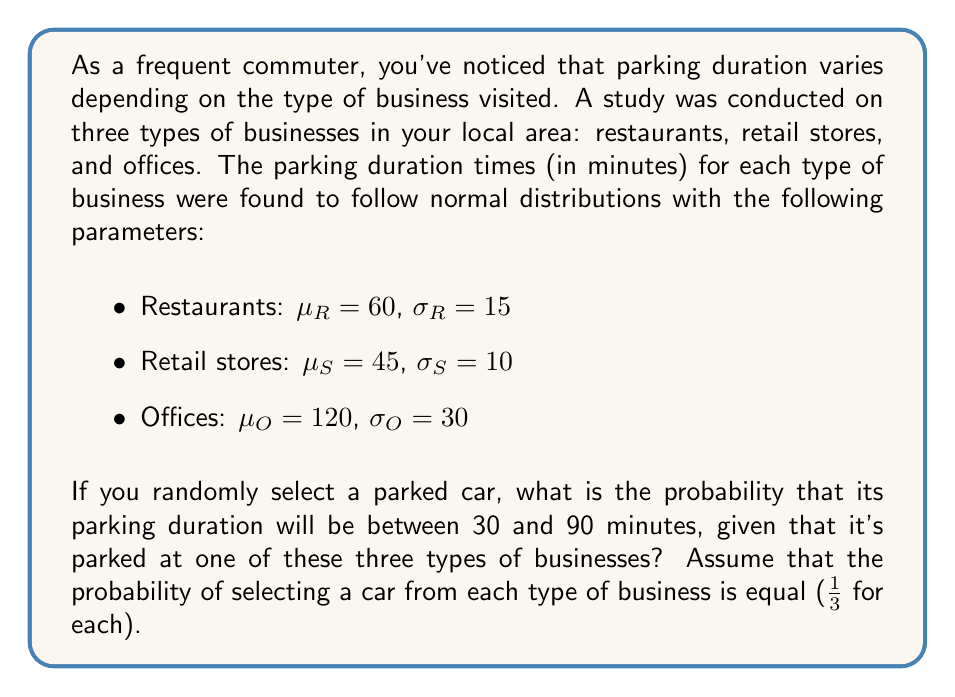What is the answer to this math problem? Let's approach this step-by-step:

1) We need to calculate the probability for each type of business and then take the weighted average.

2) For each business type, we need to find $P(30 < X < 90)$ where X is the parking duration.

3) For a normal distribution, we can standardize the values and use the standard normal distribution table or a calculator. The formula for standardization is:

   $Z = \frac{X - \mu}{\sigma}$

4) For restaurants:
   $Z_{30} = \frac{30 - 60}{15} = -2$
   $Z_{90} = \frac{90 - 60}{15} = 2$
   $P(30 < X_R < 90) = P(-2 < Z < 2) = 0.9545$

5) For retail stores:
   $Z_{30} = \frac{30 - 45}{10} = -1.5$
   $Z_{90} = \frac{90 - 45}{10} = 4.5$
   $P(30 < X_S < 90) = P(-1.5 < Z < 4.5) = 0.9332$

6) For offices:
   $Z_{30} = \frac{30 - 120}{30} = -3$
   $Z_{90} = \frac{90 - 120}{30} = -1$
   $P(30 < X_O < 90) = P(-3 < Z < -1) = 0.1587$

7) Now, we take the weighted average of these probabilities:

   $P(30 < X < 90) = \frac{1}{3}(0.9545 + 0.9332 + 0.1587) = 0.6821$

Therefore, the probability is approximately 0.6821 or 68.21%.
Answer: 0.6821 